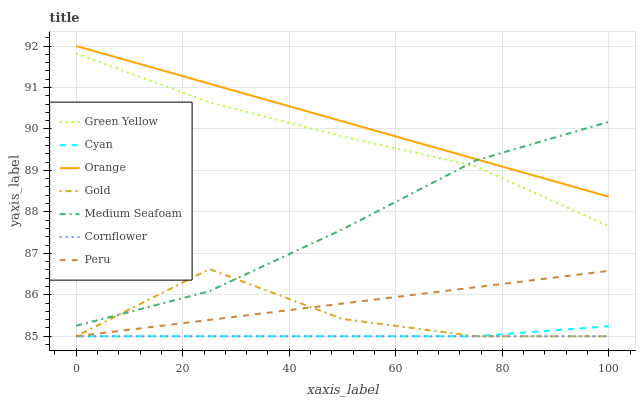Does Cornflower have the minimum area under the curve?
Answer yes or no. Yes. Does Orange have the maximum area under the curve?
Answer yes or no. Yes. Does Gold have the minimum area under the curve?
Answer yes or no. No. Does Gold have the maximum area under the curve?
Answer yes or no. No. Is Cornflower the smoothest?
Answer yes or no. Yes. Is Gold the roughest?
Answer yes or no. Yes. Is Gold the smoothest?
Answer yes or no. No. Is Peru the roughest?
Answer yes or no. No. Does Orange have the lowest value?
Answer yes or no. No. Does Orange have the highest value?
Answer yes or no. Yes. Does Gold have the highest value?
Answer yes or no. No. Is Cyan less than Orange?
Answer yes or no. Yes. Is Orange greater than Cornflower?
Answer yes or no. Yes. Does Cyan intersect Peru?
Answer yes or no. Yes. Is Cyan less than Peru?
Answer yes or no. No. Is Cyan greater than Peru?
Answer yes or no. No. Does Cyan intersect Orange?
Answer yes or no. No. 